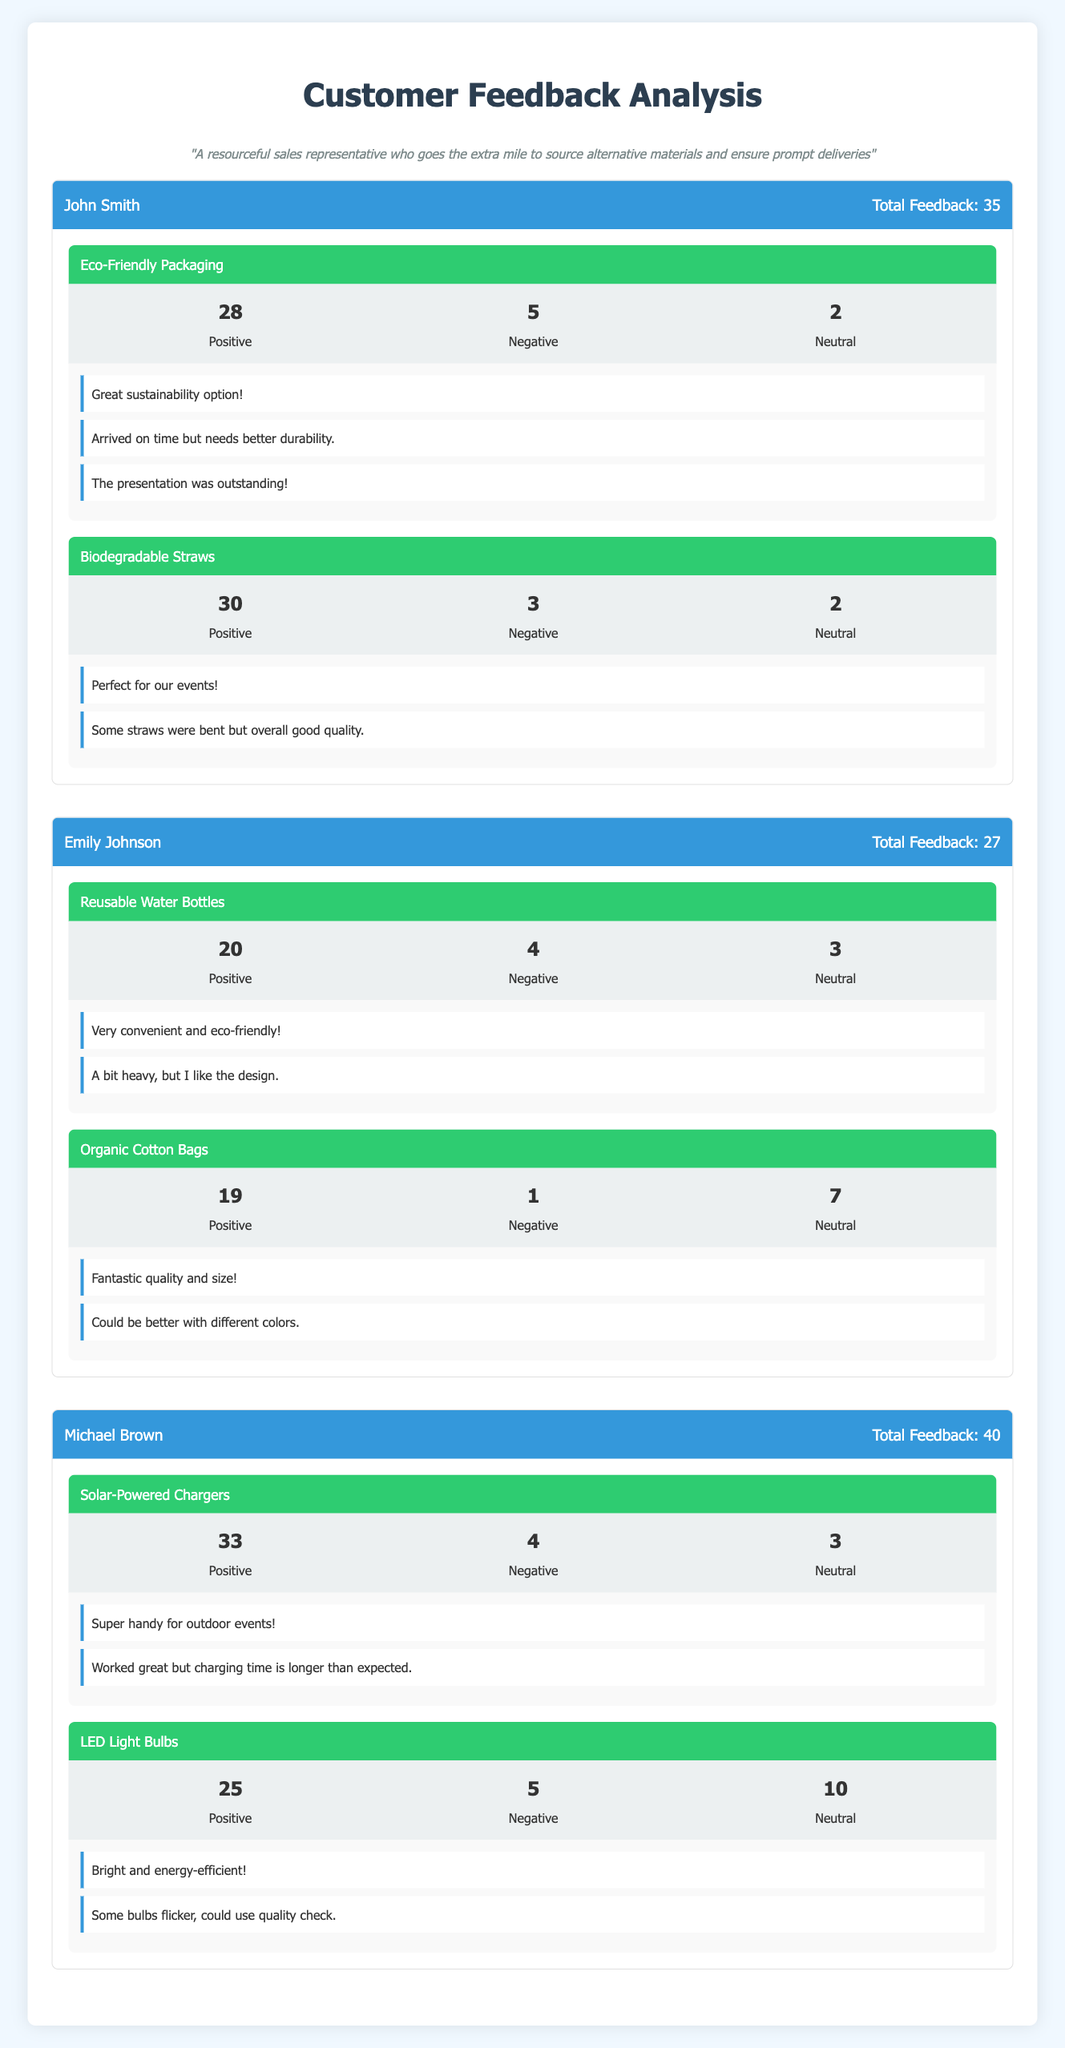What is the total feedback received for Michael Brown? The total feedback for Michael Brown is stated directly in the header of his section in the table as "Total Feedback: 40."
Answer: 40 Which product had the highest positive feedback from John Smith? To find this, we compare the positive feedback of John's two products: Eco-Friendly Packaging (28) and Biodegradable Straws (30). The product "Biodegradable Straws" has the highest positive feedback of 30.
Answer: Biodegradable Straws How many negative feedbacks did Emily Johnson receive for her products combined? Adding the negative feedback from both of Emily's products: Reusable Water Bottles (4) and Organic Cotton Bags (1) gives us a total of 4 + 1 = 5 negative feedbacks.
Answer: 5 Is the positive feedback for Solar-Powered Chargers greater than the positive feedback for LED Light Bulbs? The positive feedback for Solar-Powered Chargers is 33, while for LED Light Bulbs it is 25. Since 33 is greater than 25, the positive feedback for Solar-Powered Chargers is indeed greater.
Answer: Yes What is the average number of neutral feedbacks across all products from all sales representatives? The total neutral feedbacks are calculated by adding them up: 2 (Eco-Friendly Packaging) + 2 (Biodegradable Straws) + 3 (Reusable Water Bottles) + 7 (Organic Cotton Bags) + 3 (Solar-Powered Chargers) + 10 (LED Light Bulbs) = 27. Then, there are 6 products in total, so the average is 27 / 6 = 4.5.
Answer: 4.5 Which sales representative received the highest total feedback? By comparing the total feedback for each representative: John Smith (35), Emily Johnson (27), and Michael Brown (40), it is clear that Michael Brown received the highest total feedback.
Answer: Michael Brown What percentage of feedback for the Organic Cotton Bags was negative? The negative feedback for Organic Cotton Bags is 1 out of the total feedback of 27 (19 positive + 1 negative + 7 neutral = 27). To find the percentage, we calculate (1/27) * 100 which equals approximately 3.7%.
Answer: 3.7% How many positive feedbacks did Michael Brown receive in total for his products? Michael Brown received positive feedback for Solar-Powered Chargers (33) and for LED Light Bulbs (25). Adding these two values gives us 33 + 25 = 58 positive feedbacks in total.
Answer: 58 Did any of the products have the same level of neutral feedback? Yes, both products under John Smith (Eco-Friendly Packaging and Biodegradable Straws) each have neutral feedback of 2, indicating they have the same level of neutral feedback.
Answer: Yes 